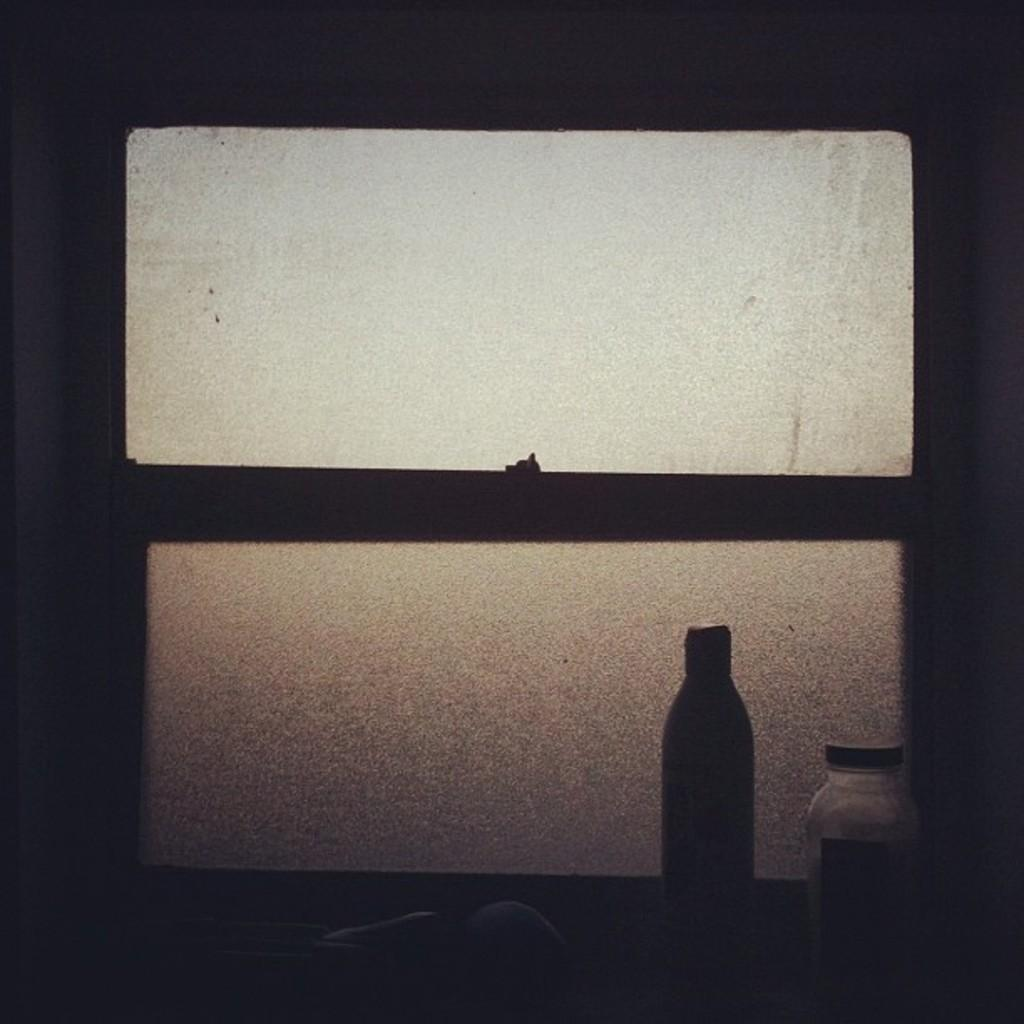What is located at the center of the image? There is a window at the center of the image. What can be seen on the right side of the image? There is a bottle at the right side of the image. What letters are visible on the moon in the image? There is no moon present in the image, and therefore no letters can be seen on it. What type of lip can be seen interacting with the bottle in the image? There is no lip present in the image; only the window and bottle are visible. 